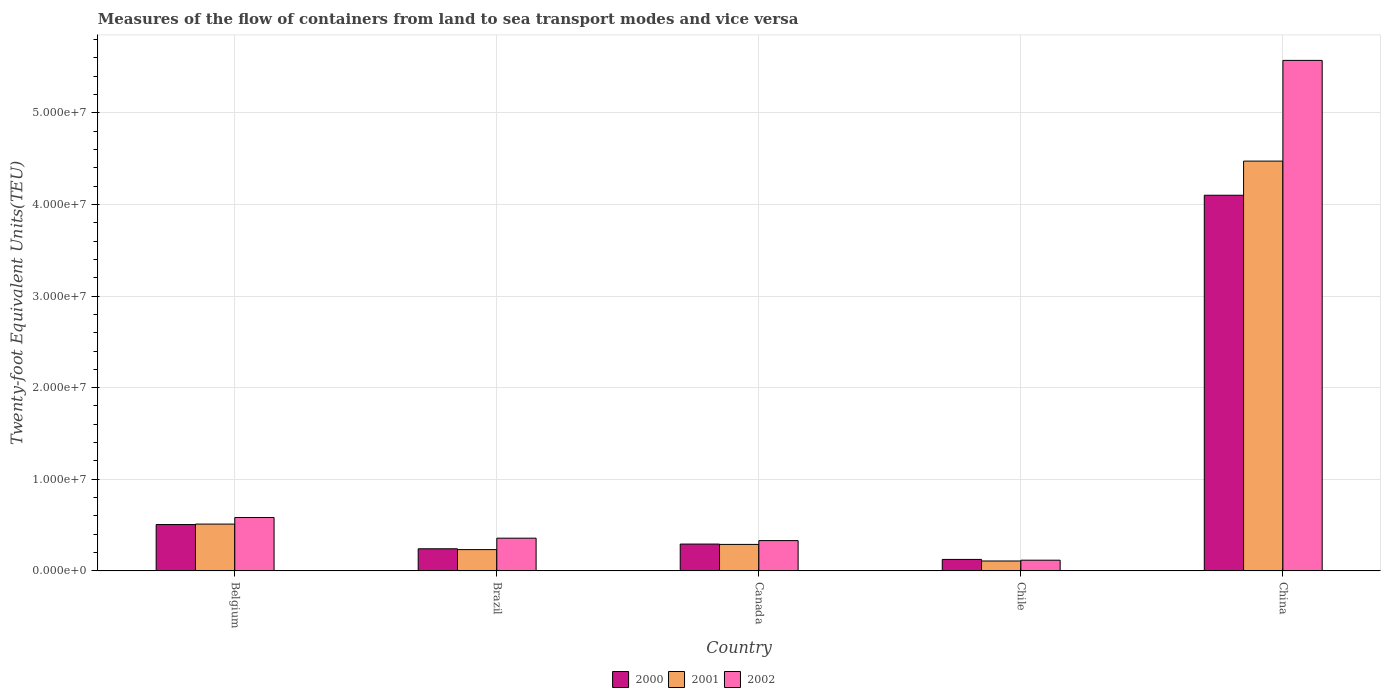How many different coloured bars are there?
Keep it short and to the point. 3. How many groups of bars are there?
Ensure brevity in your answer.  5. Are the number of bars per tick equal to the number of legend labels?
Ensure brevity in your answer.  Yes. Are the number of bars on each tick of the X-axis equal?
Give a very brief answer. Yes. What is the container port traffic in 2002 in Brazil?
Give a very brief answer. 3.57e+06. Across all countries, what is the maximum container port traffic in 2001?
Ensure brevity in your answer.  4.47e+07. Across all countries, what is the minimum container port traffic in 2002?
Offer a very short reply. 1.17e+06. In which country was the container port traffic in 2000 maximum?
Your answer should be compact. China. In which country was the container port traffic in 2000 minimum?
Offer a very short reply. Chile. What is the total container port traffic in 2001 in the graph?
Provide a short and direct response. 5.61e+07. What is the difference between the container port traffic in 2000 in Chile and that in China?
Your response must be concise. -3.97e+07. What is the difference between the container port traffic in 2001 in Chile and the container port traffic in 2000 in China?
Provide a succinct answer. -3.99e+07. What is the average container port traffic in 2002 per country?
Provide a short and direct response. 1.39e+07. What is the difference between the container port traffic of/in 2002 and container port traffic of/in 2000 in Brazil?
Offer a very short reply. 1.16e+06. What is the ratio of the container port traffic in 2001 in Belgium to that in China?
Offer a very short reply. 0.11. Is the container port traffic in 2001 in Canada less than that in Chile?
Provide a short and direct response. No. What is the difference between the highest and the second highest container port traffic in 2000?
Keep it short and to the point. 3.59e+07. What is the difference between the highest and the lowest container port traffic in 2000?
Make the answer very short. 3.97e+07. What does the 2nd bar from the left in Belgium represents?
Your answer should be very brief. 2001. What does the 3rd bar from the right in China represents?
Your answer should be very brief. 2000. Is it the case that in every country, the sum of the container port traffic in 2000 and container port traffic in 2001 is greater than the container port traffic in 2002?
Keep it short and to the point. Yes. Does the graph contain any zero values?
Make the answer very short. No. What is the title of the graph?
Make the answer very short. Measures of the flow of containers from land to sea transport modes and vice versa. Does "2011" appear as one of the legend labels in the graph?
Make the answer very short. No. What is the label or title of the Y-axis?
Offer a terse response. Twenty-foot Equivalent Units(TEU). What is the Twenty-foot Equivalent Units(TEU) in 2000 in Belgium?
Offer a terse response. 5.06e+06. What is the Twenty-foot Equivalent Units(TEU) in 2001 in Belgium?
Ensure brevity in your answer.  5.11e+06. What is the Twenty-foot Equivalent Units(TEU) of 2002 in Belgium?
Offer a terse response. 5.83e+06. What is the Twenty-foot Equivalent Units(TEU) of 2000 in Brazil?
Provide a short and direct response. 2.41e+06. What is the Twenty-foot Equivalent Units(TEU) of 2001 in Brazil?
Your response must be concise. 2.32e+06. What is the Twenty-foot Equivalent Units(TEU) in 2002 in Brazil?
Provide a succinct answer. 3.57e+06. What is the Twenty-foot Equivalent Units(TEU) of 2000 in Canada?
Your response must be concise. 2.93e+06. What is the Twenty-foot Equivalent Units(TEU) of 2001 in Canada?
Your answer should be compact. 2.89e+06. What is the Twenty-foot Equivalent Units(TEU) of 2002 in Canada?
Your answer should be very brief. 3.31e+06. What is the Twenty-foot Equivalent Units(TEU) of 2000 in Chile?
Ensure brevity in your answer.  1.25e+06. What is the Twenty-foot Equivalent Units(TEU) in 2001 in Chile?
Ensure brevity in your answer.  1.08e+06. What is the Twenty-foot Equivalent Units(TEU) in 2002 in Chile?
Provide a succinct answer. 1.17e+06. What is the Twenty-foot Equivalent Units(TEU) of 2000 in China?
Offer a very short reply. 4.10e+07. What is the Twenty-foot Equivalent Units(TEU) in 2001 in China?
Your answer should be compact. 4.47e+07. What is the Twenty-foot Equivalent Units(TEU) in 2002 in China?
Make the answer very short. 5.57e+07. Across all countries, what is the maximum Twenty-foot Equivalent Units(TEU) in 2000?
Your answer should be very brief. 4.10e+07. Across all countries, what is the maximum Twenty-foot Equivalent Units(TEU) of 2001?
Your response must be concise. 4.47e+07. Across all countries, what is the maximum Twenty-foot Equivalent Units(TEU) in 2002?
Provide a succinct answer. 5.57e+07. Across all countries, what is the minimum Twenty-foot Equivalent Units(TEU) of 2000?
Give a very brief answer. 1.25e+06. Across all countries, what is the minimum Twenty-foot Equivalent Units(TEU) of 2001?
Your answer should be compact. 1.08e+06. Across all countries, what is the minimum Twenty-foot Equivalent Units(TEU) of 2002?
Your answer should be compact. 1.17e+06. What is the total Twenty-foot Equivalent Units(TEU) of 2000 in the graph?
Offer a terse response. 5.27e+07. What is the total Twenty-foot Equivalent Units(TEU) in 2001 in the graph?
Offer a terse response. 5.61e+07. What is the total Twenty-foot Equivalent Units(TEU) of 2002 in the graph?
Your response must be concise. 6.96e+07. What is the difference between the Twenty-foot Equivalent Units(TEU) in 2000 in Belgium and that in Brazil?
Provide a short and direct response. 2.64e+06. What is the difference between the Twenty-foot Equivalent Units(TEU) in 2001 in Belgium and that in Brazil?
Your answer should be very brief. 2.79e+06. What is the difference between the Twenty-foot Equivalent Units(TEU) of 2002 in Belgium and that in Brazil?
Make the answer very short. 2.26e+06. What is the difference between the Twenty-foot Equivalent Units(TEU) of 2000 in Belgium and that in Canada?
Offer a terse response. 2.13e+06. What is the difference between the Twenty-foot Equivalent Units(TEU) of 2001 in Belgium and that in Canada?
Give a very brief answer. 2.22e+06. What is the difference between the Twenty-foot Equivalent Units(TEU) in 2002 in Belgium and that in Canada?
Offer a terse response. 2.52e+06. What is the difference between the Twenty-foot Equivalent Units(TEU) in 2000 in Belgium and that in Chile?
Offer a very short reply. 3.80e+06. What is the difference between the Twenty-foot Equivalent Units(TEU) in 2001 in Belgium and that in Chile?
Offer a very short reply. 4.03e+06. What is the difference between the Twenty-foot Equivalent Units(TEU) of 2002 in Belgium and that in Chile?
Your answer should be compact. 4.66e+06. What is the difference between the Twenty-foot Equivalent Units(TEU) of 2000 in Belgium and that in China?
Your response must be concise. -3.59e+07. What is the difference between the Twenty-foot Equivalent Units(TEU) in 2001 in Belgium and that in China?
Give a very brief answer. -3.96e+07. What is the difference between the Twenty-foot Equivalent Units(TEU) in 2002 in Belgium and that in China?
Ensure brevity in your answer.  -4.99e+07. What is the difference between the Twenty-foot Equivalent Units(TEU) in 2000 in Brazil and that in Canada?
Offer a terse response. -5.15e+05. What is the difference between the Twenty-foot Equivalent Units(TEU) of 2001 in Brazil and that in Canada?
Offer a terse response. -5.67e+05. What is the difference between the Twenty-foot Equivalent Units(TEU) of 2002 in Brazil and that in Canada?
Your answer should be compact. 2.63e+05. What is the difference between the Twenty-foot Equivalent Units(TEU) of 2000 in Brazil and that in Chile?
Give a very brief answer. 1.16e+06. What is the difference between the Twenty-foot Equivalent Units(TEU) of 2001 in Brazil and that in Chile?
Offer a terse response. 1.24e+06. What is the difference between the Twenty-foot Equivalent Units(TEU) in 2002 in Brazil and that in Chile?
Your response must be concise. 2.40e+06. What is the difference between the Twenty-foot Equivalent Units(TEU) in 2000 in Brazil and that in China?
Offer a very short reply. -3.86e+07. What is the difference between the Twenty-foot Equivalent Units(TEU) in 2001 in Brazil and that in China?
Your response must be concise. -4.24e+07. What is the difference between the Twenty-foot Equivalent Units(TEU) of 2002 in Brazil and that in China?
Provide a short and direct response. -5.21e+07. What is the difference between the Twenty-foot Equivalent Units(TEU) in 2000 in Canada and that in Chile?
Ensure brevity in your answer.  1.67e+06. What is the difference between the Twenty-foot Equivalent Units(TEU) of 2001 in Canada and that in Chile?
Provide a short and direct response. 1.81e+06. What is the difference between the Twenty-foot Equivalent Units(TEU) in 2002 in Canada and that in Chile?
Offer a very short reply. 2.14e+06. What is the difference between the Twenty-foot Equivalent Units(TEU) of 2000 in Canada and that in China?
Keep it short and to the point. -3.81e+07. What is the difference between the Twenty-foot Equivalent Units(TEU) of 2001 in Canada and that in China?
Provide a short and direct response. -4.18e+07. What is the difference between the Twenty-foot Equivalent Units(TEU) of 2002 in Canada and that in China?
Your answer should be very brief. -5.24e+07. What is the difference between the Twenty-foot Equivalent Units(TEU) in 2000 in Chile and that in China?
Offer a very short reply. -3.97e+07. What is the difference between the Twenty-foot Equivalent Units(TEU) of 2001 in Chile and that in China?
Provide a succinct answer. -4.36e+07. What is the difference between the Twenty-foot Equivalent Units(TEU) in 2002 in Chile and that in China?
Provide a succinct answer. -5.45e+07. What is the difference between the Twenty-foot Equivalent Units(TEU) in 2000 in Belgium and the Twenty-foot Equivalent Units(TEU) in 2001 in Brazil?
Keep it short and to the point. 2.73e+06. What is the difference between the Twenty-foot Equivalent Units(TEU) of 2000 in Belgium and the Twenty-foot Equivalent Units(TEU) of 2002 in Brazil?
Your answer should be very brief. 1.49e+06. What is the difference between the Twenty-foot Equivalent Units(TEU) of 2001 in Belgium and the Twenty-foot Equivalent Units(TEU) of 2002 in Brazil?
Offer a very short reply. 1.54e+06. What is the difference between the Twenty-foot Equivalent Units(TEU) in 2000 in Belgium and the Twenty-foot Equivalent Units(TEU) in 2001 in Canada?
Your answer should be very brief. 2.17e+06. What is the difference between the Twenty-foot Equivalent Units(TEU) of 2000 in Belgium and the Twenty-foot Equivalent Units(TEU) of 2002 in Canada?
Your answer should be very brief. 1.75e+06. What is the difference between the Twenty-foot Equivalent Units(TEU) of 2001 in Belgium and the Twenty-foot Equivalent Units(TEU) of 2002 in Canada?
Provide a succinct answer. 1.80e+06. What is the difference between the Twenty-foot Equivalent Units(TEU) in 2000 in Belgium and the Twenty-foot Equivalent Units(TEU) in 2001 in Chile?
Your response must be concise. 3.98e+06. What is the difference between the Twenty-foot Equivalent Units(TEU) of 2000 in Belgium and the Twenty-foot Equivalent Units(TEU) of 2002 in Chile?
Provide a succinct answer. 3.89e+06. What is the difference between the Twenty-foot Equivalent Units(TEU) of 2001 in Belgium and the Twenty-foot Equivalent Units(TEU) of 2002 in Chile?
Your response must be concise. 3.94e+06. What is the difference between the Twenty-foot Equivalent Units(TEU) of 2000 in Belgium and the Twenty-foot Equivalent Units(TEU) of 2001 in China?
Offer a very short reply. -3.97e+07. What is the difference between the Twenty-foot Equivalent Units(TEU) in 2000 in Belgium and the Twenty-foot Equivalent Units(TEU) in 2002 in China?
Offer a very short reply. -5.07e+07. What is the difference between the Twenty-foot Equivalent Units(TEU) of 2001 in Belgium and the Twenty-foot Equivalent Units(TEU) of 2002 in China?
Your answer should be compact. -5.06e+07. What is the difference between the Twenty-foot Equivalent Units(TEU) in 2000 in Brazil and the Twenty-foot Equivalent Units(TEU) in 2001 in Canada?
Your answer should be very brief. -4.77e+05. What is the difference between the Twenty-foot Equivalent Units(TEU) of 2000 in Brazil and the Twenty-foot Equivalent Units(TEU) of 2002 in Canada?
Offer a terse response. -8.94e+05. What is the difference between the Twenty-foot Equivalent Units(TEU) of 2001 in Brazil and the Twenty-foot Equivalent Units(TEU) of 2002 in Canada?
Give a very brief answer. -9.84e+05. What is the difference between the Twenty-foot Equivalent Units(TEU) of 2000 in Brazil and the Twenty-foot Equivalent Units(TEU) of 2001 in Chile?
Provide a succinct answer. 1.33e+06. What is the difference between the Twenty-foot Equivalent Units(TEU) in 2000 in Brazil and the Twenty-foot Equivalent Units(TEU) in 2002 in Chile?
Offer a very short reply. 1.25e+06. What is the difference between the Twenty-foot Equivalent Units(TEU) of 2001 in Brazil and the Twenty-foot Equivalent Units(TEU) of 2002 in Chile?
Keep it short and to the point. 1.16e+06. What is the difference between the Twenty-foot Equivalent Units(TEU) of 2000 in Brazil and the Twenty-foot Equivalent Units(TEU) of 2001 in China?
Your answer should be very brief. -4.23e+07. What is the difference between the Twenty-foot Equivalent Units(TEU) in 2000 in Brazil and the Twenty-foot Equivalent Units(TEU) in 2002 in China?
Provide a succinct answer. -5.33e+07. What is the difference between the Twenty-foot Equivalent Units(TEU) in 2001 in Brazil and the Twenty-foot Equivalent Units(TEU) in 2002 in China?
Give a very brief answer. -5.34e+07. What is the difference between the Twenty-foot Equivalent Units(TEU) of 2000 in Canada and the Twenty-foot Equivalent Units(TEU) of 2001 in Chile?
Offer a terse response. 1.85e+06. What is the difference between the Twenty-foot Equivalent Units(TEU) of 2000 in Canada and the Twenty-foot Equivalent Units(TEU) of 2002 in Chile?
Provide a short and direct response. 1.76e+06. What is the difference between the Twenty-foot Equivalent Units(TEU) in 2001 in Canada and the Twenty-foot Equivalent Units(TEU) in 2002 in Chile?
Give a very brief answer. 1.72e+06. What is the difference between the Twenty-foot Equivalent Units(TEU) of 2000 in Canada and the Twenty-foot Equivalent Units(TEU) of 2001 in China?
Make the answer very short. -4.18e+07. What is the difference between the Twenty-foot Equivalent Units(TEU) of 2000 in Canada and the Twenty-foot Equivalent Units(TEU) of 2002 in China?
Provide a succinct answer. -5.28e+07. What is the difference between the Twenty-foot Equivalent Units(TEU) in 2001 in Canada and the Twenty-foot Equivalent Units(TEU) in 2002 in China?
Give a very brief answer. -5.28e+07. What is the difference between the Twenty-foot Equivalent Units(TEU) of 2000 in Chile and the Twenty-foot Equivalent Units(TEU) of 2001 in China?
Give a very brief answer. -4.35e+07. What is the difference between the Twenty-foot Equivalent Units(TEU) in 2000 in Chile and the Twenty-foot Equivalent Units(TEU) in 2002 in China?
Make the answer very short. -5.45e+07. What is the difference between the Twenty-foot Equivalent Units(TEU) of 2001 in Chile and the Twenty-foot Equivalent Units(TEU) of 2002 in China?
Your answer should be very brief. -5.46e+07. What is the average Twenty-foot Equivalent Units(TEU) of 2000 per country?
Provide a succinct answer. 1.05e+07. What is the average Twenty-foot Equivalent Units(TEU) in 2001 per country?
Offer a terse response. 1.12e+07. What is the average Twenty-foot Equivalent Units(TEU) in 2002 per country?
Give a very brief answer. 1.39e+07. What is the difference between the Twenty-foot Equivalent Units(TEU) of 2000 and Twenty-foot Equivalent Units(TEU) of 2001 in Belgium?
Your answer should be compact. -5.21e+04. What is the difference between the Twenty-foot Equivalent Units(TEU) of 2000 and Twenty-foot Equivalent Units(TEU) of 2002 in Belgium?
Offer a terse response. -7.68e+05. What is the difference between the Twenty-foot Equivalent Units(TEU) in 2001 and Twenty-foot Equivalent Units(TEU) in 2002 in Belgium?
Provide a succinct answer. -7.16e+05. What is the difference between the Twenty-foot Equivalent Units(TEU) of 2000 and Twenty-foot Equivalent Units(TEU) of 2001 in Brazil?
Provide a succinct answer. 8.93e+04. What is the difference between the Twenty-foot Equivalent Units(TEU) of 2000 and Twenty-foot Equivalent Units(TEU) of 2002 in Brazil?
Your answer should be compact. -1.16e+06. What is the difference between the Twenty-foot Equivalent Units(TEU) of 2001 and Twenty-foot Equivalent Units(TEU) of 2002 in Brazil?
Give a very brief answer. -1.25e+06. What is the difference between the Twenty-foot Equivalent Units(TEU) in 2000 and Twenty-foot Equivalent Units(TEU) in 2001 in Canada?
Your response must be concise. 3.76e+04. What is the difference between the Twenty-foot Equivalent Units(TEU) in 2000 and Twenty-foot Equivalent Units(TEU) in 2002 in Canada?
Give a very brief answer. -3.79e+05. What is the difference between the Twenty-foot Equivalent Units(TEU) in 2001 and Twenty-foot Equivalent Units(TEU) in 2002 in Canada?
Give a very brief answer. -4.17e+05. What is the difference between the Twenty-foot Equivalent Units(TEU) in 2000 and Twenty-foot Equivalent Units(TEU) in 2001 in Chile?
Your answer should be compact. 1.73e+05. What is the difference between the Twenty-foot Equivalent Units(TEU) in 2000 and Twenty-foot Equivalent Units(TEU) in 2002 in Chile?
Offer a very short reply. 8.53e+04. What is the difference between the Twenty-foot Equivalent Units(TEU) of 2001 and Twenty-foot Equivalent Units(TEU) of 2002 in Chile?
Your answer should be compact. -8.73e+04. What is the difference between the Twenty-foot Equivalent Units(TEU) of 2000 and Twenty-foot Equivalent Units(TEU) of 2001 in China?
Your response must be concise. -3.73e+06. What is the difference between the Twenty-foot Equivalent Units(TEU) in 2000 and Twenty-foot Equivalent Units(TEU) in 2002 in China?
Ensure brevity in your answer.  -1.47e+07. What is the difference between the Twenty-foot Equivalent Units(TEU) in 2001 and Twenty-foot Equivalent Units(TEU) in 2002 in China?
Provide a short and direct response. -1.10e+07. What is the ratio of the Twenty-foot Equivalent Units(TEU) of 2000 in Belgium to that in Brazil?
Your response must be concise. 2.1. What is the ratio of the Twenty-foot Equivalent Units(TEU) in 2001 in Belgium to that in Brazil?
Offer a very short reply. 2.2. What is the ratio of the Twenty-foot Equivalent Units(TEU) of 2002 in Belgium to that in Brazil?
Give a very brief answer. 1.63. What is the ratio of the Twenty-foot Equivalent Units(TEU) of 2000 in Belgium to that in Canada?
Your response must be concise. 1.73. What is the ratio of the Twenty-foot Equivalent Units(TEU) of 2001 in Belgium to that in Canada?
Keep it short and to the point. 1.77. What is the ratio of the Twenty-foot Equivalent Units(TEU) in 2002 in Belgium to that in Canada?
Keep it short and to the point. 1.76. What is the ratio of the Twenty-foot Equivalent Units(TEU) of 2000 in Belgium to that in Chile?
Your response must be concise. 4.04. What is the ratio of the Twenty-foot Equivalent Units(TEU) of 2001 in Belgium to that in Chile?
Keep it short and to the point. 4.73. What is the ratio of the Twenty-foot Equivalent Units(TEU) of 2002 in Belgium to that in Chile?
Keep it short and to the point. 4.99. What is the ratio of the Twenty-foot Equivalent Units(TEU) in 2000 in Belgium to that in China?
Your response must be concise. 0.12. What is the ratio of the Twenty-foot Equivalent Units(TEU) of 2001 in Belgium to that in China?
Your answer should be compact. 0.11. What is the ratio of the Twenty-foot Equivalent Units(TEU) of 2002 in Belgium to that in China?
Offer a terse response. 0.1. What is the ratio of the Twenty-foot Equivalent Units(TEU) of 2000 in Brazil to that in Canada?
Your answer should be very brief. 0.82. What is the ratio of the Twenty-foot Equivalent Units(TEU) of 2001 in Brazil to that in Canada?
Ensure brevity in your answer.  0.8. What is the ratio of the Twenty-foot Equivalent Units(TEU) of 2002 in Brazil to that in Canada?
Ensure brevity in your answer.  1.08. What is the ratio of the Twenty-foot Equivalent Units(TEU) in 2000 in Brazil to that in Chile?
Make the answer very short. 1.93. What is the ratio of the Twenty-foot Equivalent Units(TEU) of 2001 in Brazil to that in Chile?
Provide a short and direct response. 2.15. What is the ratio of the Twenty-foot Equivalent Units(TEU) in 2002 in Brazil to that in Chile?
Give a very brief answer. 3.06. What is the ratio of the Twenty-foot Equivalent Units(TEU) of 2000 in Brazil to that in China?
Provide a succinct answer. 0.06. What is the ratio of the Twenty-foot Equivalent Units(TEU) of 2001 in Brazil to that in China?
Ensure brevity in your answer.  0.05. What is the ratio of the Twenty-foot Equivalent Units(TEU) of 2002 in Brazil to that in China?
Your answer should be compact. 0.06. What is the ratio of the Twenty-foot Equivalent Units(TEU) of 2000 in Canada to that in Chile?
Offer a very short reply. 2.34. What is the ratio of the Twenty-foot Equivalent Units(TEU) of 2001 in Canada to that in Chile?
Ensure brevity in your answer.  2.67. What is the ratio of the Twenty-foot Equivalent Units(TEU) in 2002 in Canada to that in Chile?
Ensure brevity in your answer.  2.83. What is the ratio of the Twenty-foot Equivalent Units(TEU) in 2000 in Canada to that in China?
Your answer should be very brief. 0.07. What is the ratio of the Twenty-foot Equivalent Units(TEU) in 2001 in Canada to that in China?
Provide a succinct answer. 0.06. What is the ratio of the Twenty-foot Equivalent Units(TEU) in 2002 in Canada to that in China?
Your answer should be compact. 0.06. What is the ratio of the Twenty-foot Equivalent Units(TEU) in 2000 in Chile to that in China?
Offer a very short reply. 0.03. What is the ratio of the Twenty-foot Equivalent Units(TEU) in 2001 in Chile to that in China?
Provide a succinct answer. 0.02. What is the ratio of the Twenty-foot Equivalent Units(TEU) of 2002 in Chile to that in China?
Ensure brevity in your answer.  0.02. What is the difference between the highest and the second highest Twenty-foot Equivalent Units(TEU) in 2000?
Your answer should be compact. 3.59e+07. What is the difference between the highest and the second highest Twenty-foot Equivalent Units(TEU) of 2001?
Your answer should be very brief. 3.96e+07. What is the difference between the highest and the second highest Twenty-foot Equivalent Units(TEU) in 2002?
Your answer should be very brief. 4.99e+07. What is the difference between the highest and the lowest Twenty-foot Equivalent Units(TEU) in 2000?
Ensure brevity in your answer.  3.97e+07. What is the difference between the highest and the lowest Twenty-foot Equivalent Units(TEU) in 2001?
Provide a short and direct response. 4.36e+07. What is the difference between the highest and the lowest Twenty-foot Equivalent Units(TEU) in 2002?
Make the answer very short. 5.45e+07. 